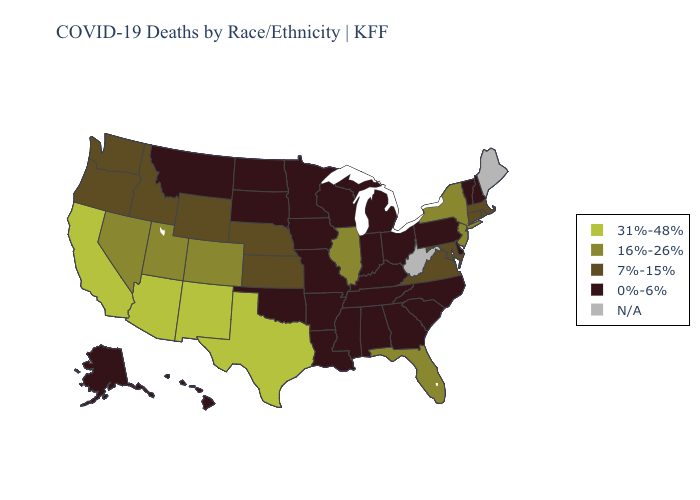Name the states that have a value in the range 7%-15%?
Write a very short answer. Connecticut, Idaho, Kansas, Maryland, Massachusetts, Nebraska, Oregon, Rhode Island, Virginia, Washington, Wyoming. Does Connecticut have the highest value in the Northeast?
Give a very brief answer. No. Name the states that have a value in the range 16%-26%?
Write a very short answer. Colorado, Florida, Illinois, Nevada, New Jersey, New York, Utah. How many symbols are there in the legend?
Quick response, please. 5. Among the states that border Nevada , does Oregon have the highest value?
Short answer required. No. What is the value of Wyoming?
Write a very short answer. 7%-15%. Does the map have missing data?
Quick response, please. Yes. Name the states that have a value in the range 7%-15%?
Write a very short answer. Connecticut, Idaho, Kansas, Maryland, Massachusetts, Nebraska, Oregon, Rhode Island, Virginia, Washington, Wyoming. Does Louisiana have the highest value in the USA?
Answer briefly. No. What is the value of West Virginia?
Short answer required. N/A. Does Michigan have the lowest value in the USA?
Give a very brief answer. Yes. Name the states that have a value in the range 31%-48%?
Short answer required. Arizona, California, New Mexico, Texas. What is the highest value in the West ?
Concise answer only. 31%-48%. Does the map have missing data?
Be succinct. Yes. 